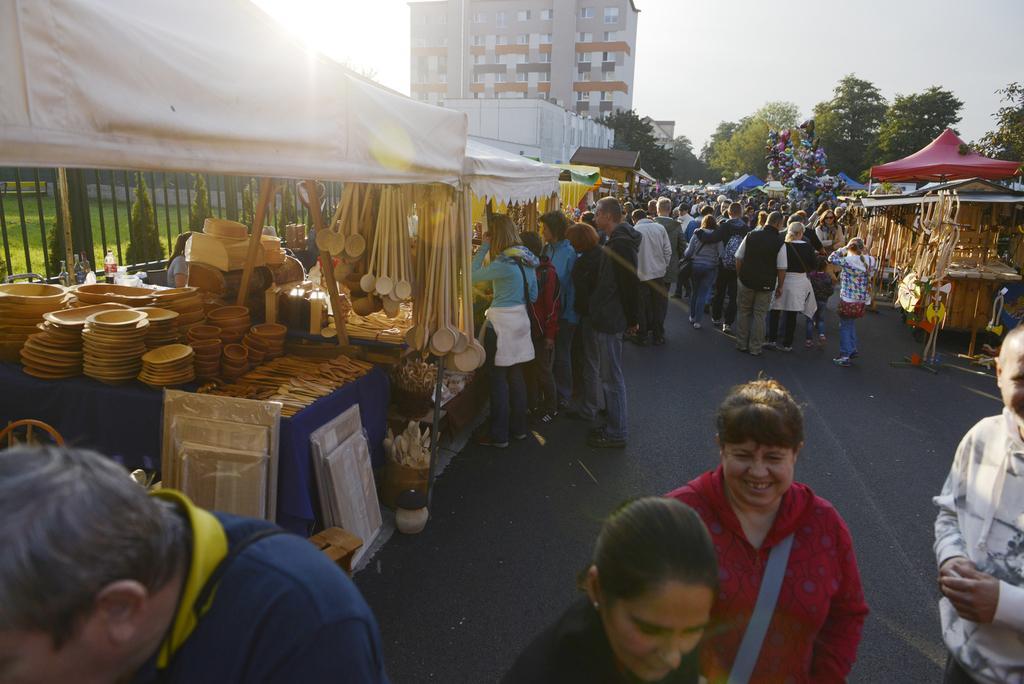Could you give a brief overview of what you see in this image? I can see groups of people walking and few people standing. These are the shops. I can see the canopy tents. Here is the building with windows. These are the trees. I can see wooden plates, bowls, serving spoons and few other things under the tent. This looks like an iron grill. I think this is the market. 